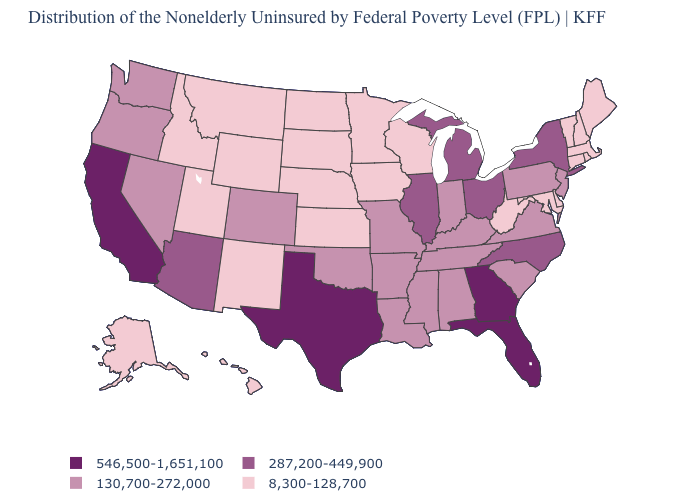Which states have the highest value in the USA?
Give a very brief answer. California, Florida, Georgia, Texas. Which states have the highest value in the USA?
Be succinct. California, Florida, Georgia, Texas. What is the value of Maine?
Be succinct. 8,300-128,700. What is the value of Illinois?
Quick response, please. 287,200-449,900. What is the value of New Hampshire?
Answer briefly. 8,300-128,700. Name the states that have a value in the range 130,700-272,000?
Concise answer only. Alabama, Arkansas, Colorado, Indiana, Kentucky, Louisiana, Mississippi, Missouri, Nevada, New Jersey, Oklahoma, Oregon, Pennsylvania, South Carolina, Tennessee, Virginia, Washington. Which states have the highest value in the USA?
Answer briefly. California, Florida, Georgia, Texas. Name the states that have a value in the range 8,300-128,700?
Short answer required. Alaska, Connecticut, Delaware, Hawaii, Idaho, Iowa, Kansas, Maine, Maryland, Massachusetts, Minnesota, Montana, Nebraska, New Hampshire, New Mexico, North Dakota, Rhode Island, South Dakota, Utah, Vermont, West Virginia, Wisconsin, Wyoming. What is the highest value in states that border Minnesota?
Be succinct. 8,300-128,700. Is the legend a continuous bar?
Give a very brief answer. No. What is the value of New Jersey?
Be succinct. 130,700-272,000. Which states have the lowest value in the MidWest?
Concise answer only. Iowa, Kansas, Minnesota, Nebraska, North Dakota, South Dakota, Wisconsin. Does New Jersey have the same value as Illinois?
Give a very brief answer. No. What is the value of New Jersey?
Give a very brief answer. 130,700-272,000. Which states have the lowest value in the USA?
Concise answer only. Alaska, Connecticut, Delaware, Hawaii, Idaho, Iowa, Kansas, Maine, Maryland, Massachusetts, Minnesota, Montana, Nebraska, New Hampshire, New Mexico, North Dakota, Rhode Island, South Dakota, Utah, Vermont, West Virginia, Wisconsin, Wyoming. 